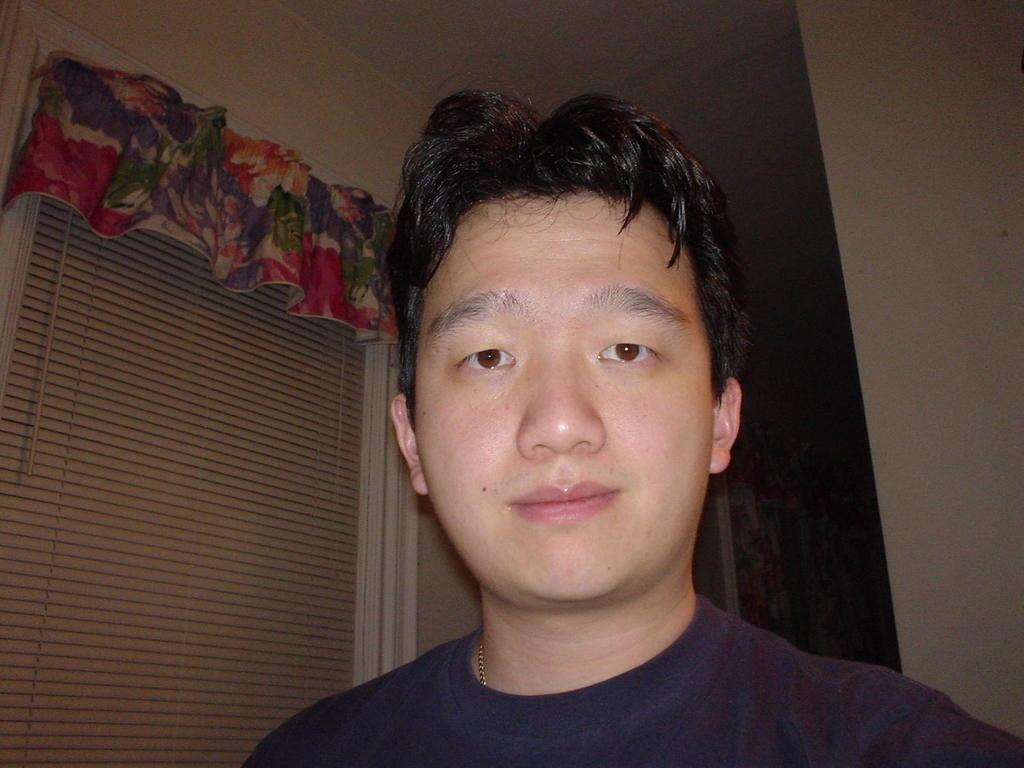Who is present in the image? There is a person in the image. What is the person wearing? The person is wearing a blue jacket. What can be seen in the background of the image? There is a window in the background of the image. What is attached to the window and the wall? There is a colorful curtain attached to the window and the wall. What type of apple is being played with by the person in the image? There is no apple present in the image, and the person is not playing with anything. 